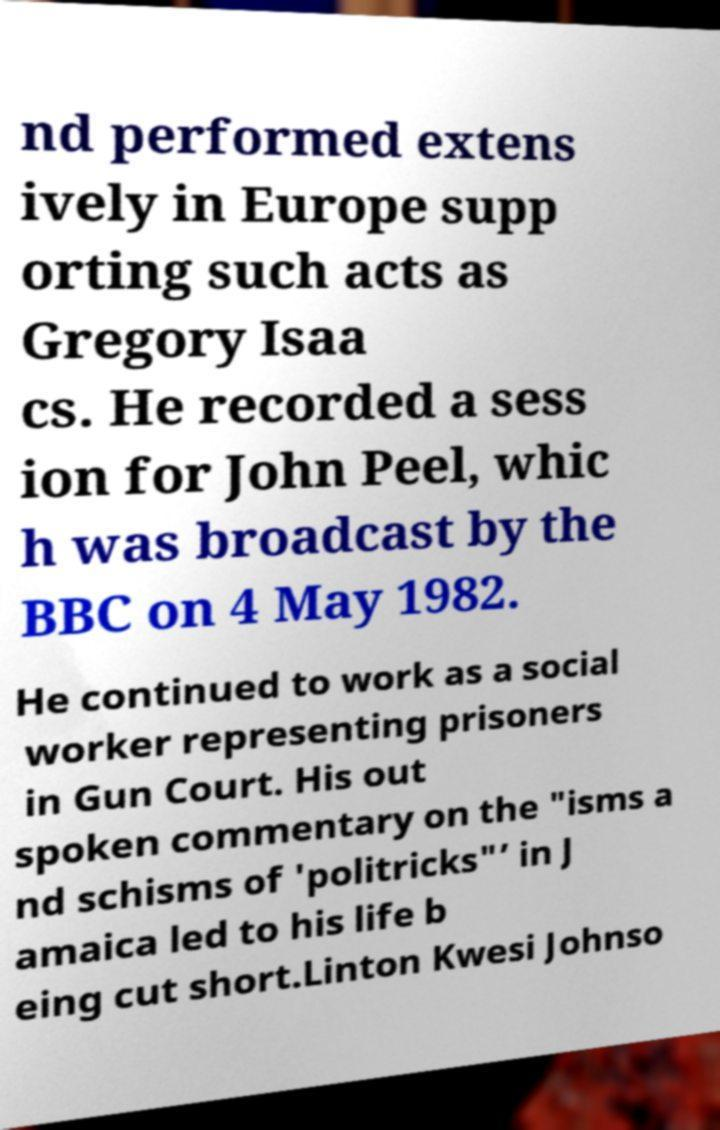There's text embedded in this image that I need extracted. Can you transcribe it verbatim? nd performed extens ively in Europe supp orting such acts as Gregory Isaa cs. He recorded a sess ion for John Peel, whic h was broadcast by the BBC on 4 May 1982. He continued to work as a social worker representing prisoners in Gun Court. His out spoken commentary on the "isms a nd schisms of 'politricks"’ in J amaica led to his life b eing cut short.Linton Kwesi Johnso 